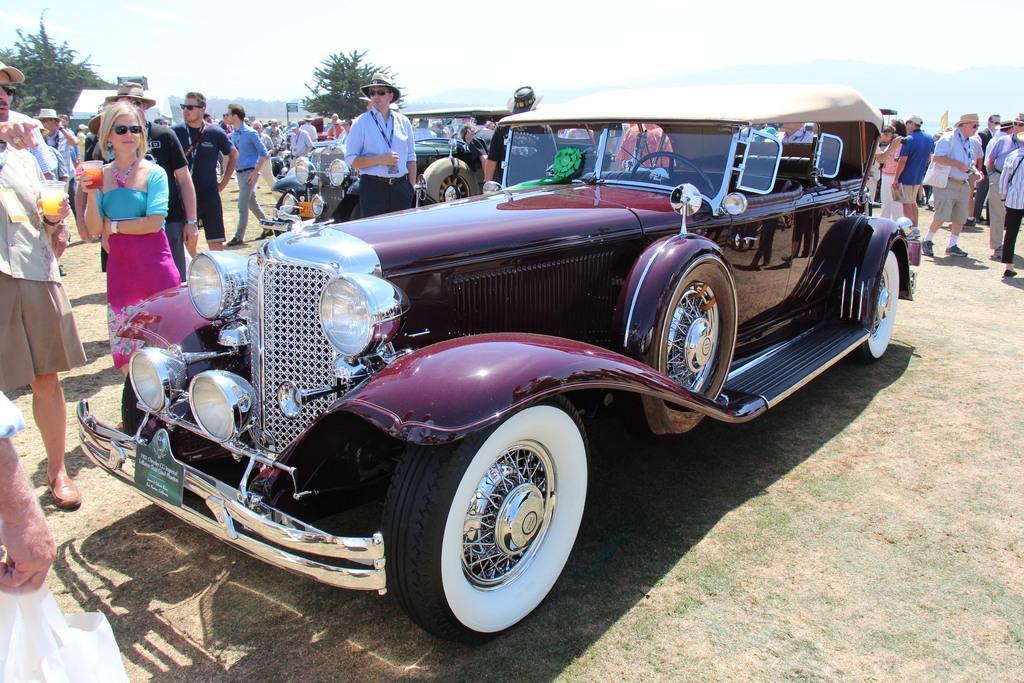Could you give a brief overview of what you see in this image? In this image there are a few people standing and walking by holding a glass of drink in their hands around two vintage cars parked, in the background of the image there are trees and mountains. 